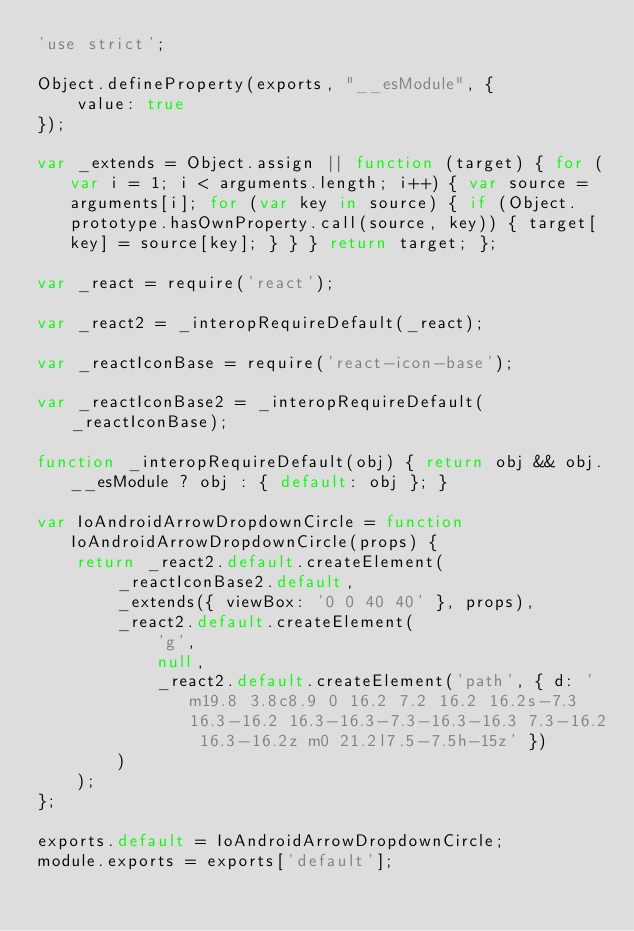Convert code to text. <code><loc_0><loc_0><loc_500><loc_500><_JavaScript_>'use strict';

Object.defineProperty(exports, "__esModule", {
    value: true
});

var _extends = Object.assign || function (target) { for (var i = 1; i < arguments.length; i++) { var source = arguments[i]; for (var key in source) { if (Object.prototype.hasOwnProperty.call(source, key)) { target[key] = source[key]; } } } return target; };

var _react = require('react');

var _react2 = _interopRequireDefault(_react);

var _reactIconBase = require('react-icon-base');

var _reactIconBase2 = _interopRequireDefault(_reactIconBase);

function _interopRequireDefault(obj) { return obj && obj.__esModule ? obj : { default: obj }; }

var IoAndroidArrowDropdownCircle = function IoAndroidArrowDropdownCircle(props) {
    return _react2.default.createElement(
        _reactIconBase2.default,
        _extends({ viewBox: '0 0 40 40' }, props),
        _react2.default.createElement(
            'g',
            null,
            _react2.default.createElement('path', { d: 'm19.8 3.8c8.9 0 16.2 7.2 16.2 16.2s-7.3 16.3-16.2 16.3-16.3-7.3-16.3-16.3 7.3-16.2 16.3-16.2z m0 21.2l7.5-7.5h-15z' })
        )
    );
};

exports.default = IoAndroidArrowDropdownCircle;
module.exports = exports['default'];</code> 